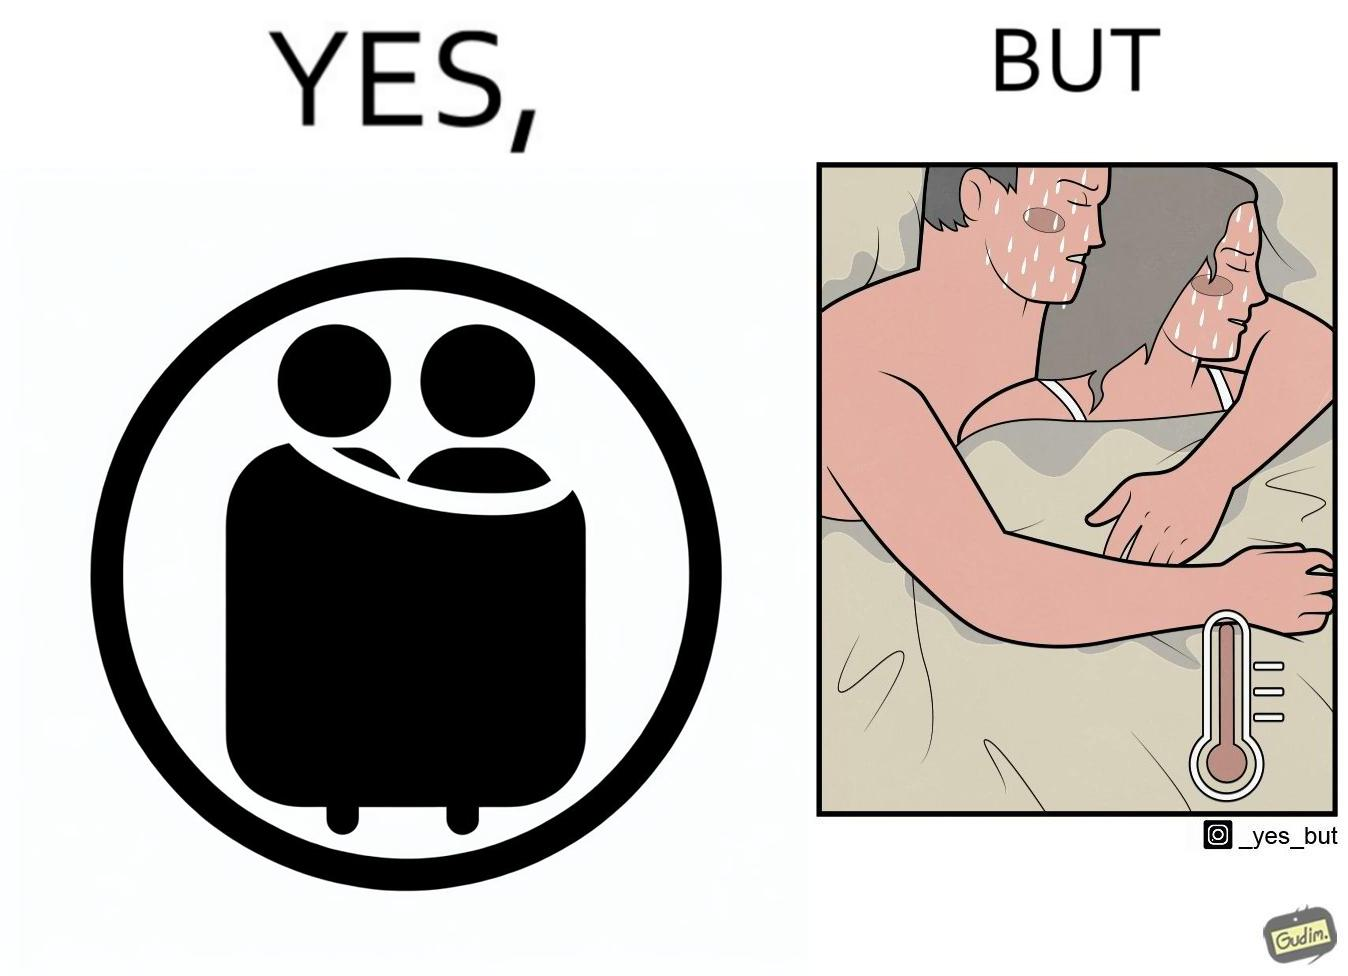What does this image depict? The image is ironic, because after some time cuddling within a blanket raises the temperature which leads to inconvenience 